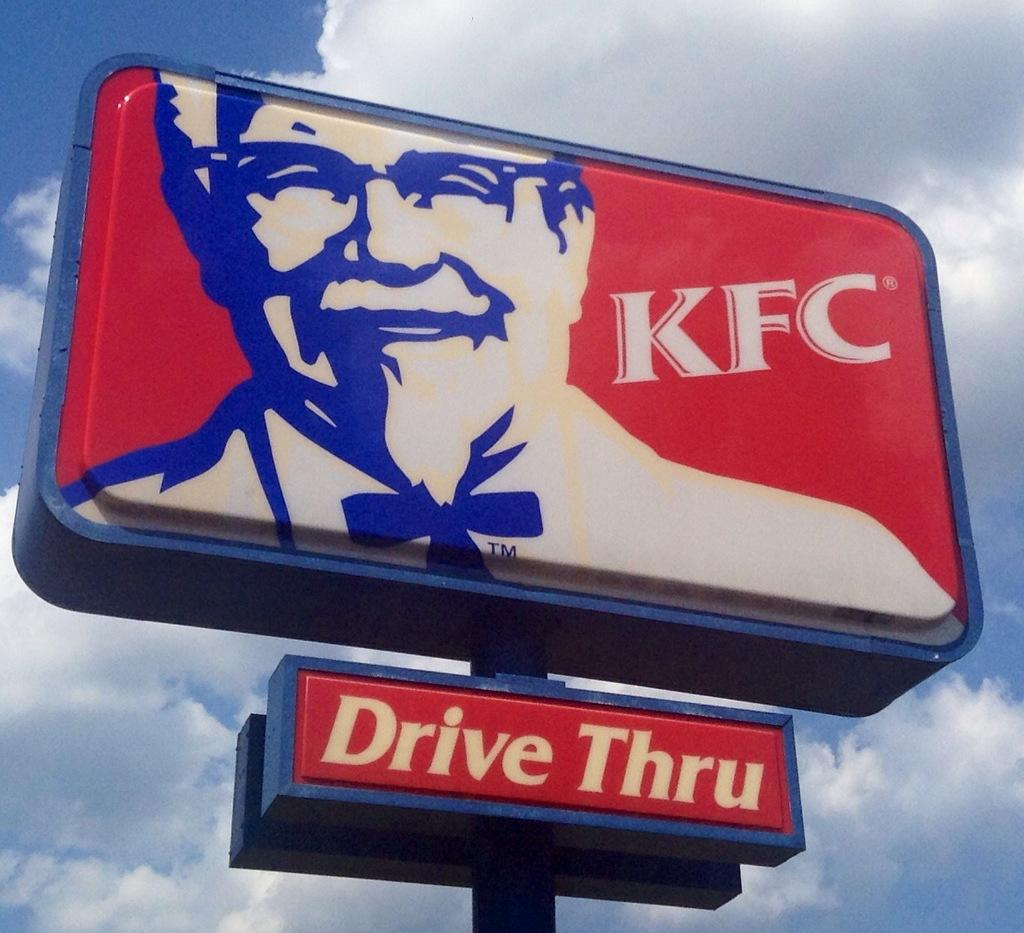<image>
Describe the image concisely. Sign showing a man's face and says KFC on it. 